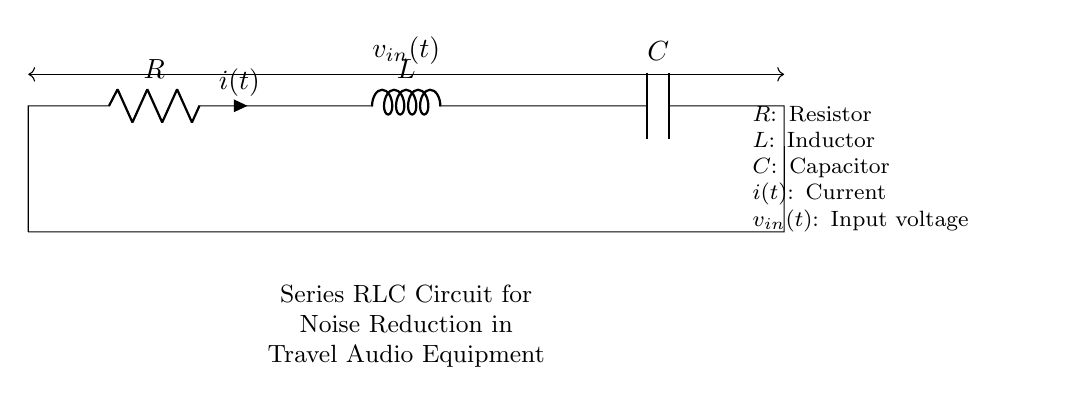What are the components of this circuit? The components listed in the circuit are Resistor, Inductor, and Capacitor, which are essential elements for filtering noise in audio equipment.
Answer: Resistor, Inductor, Capacitor What type of circuit is shown? The circuit is a Series RLC Circuit, indicated by the arrangement of the Resistor, Inductor, and Capacitor in a linear series configuration.
Answer: Series RLC Circuit What does "i(t)" represent in this circuit? "i(t)" represents the current flowing through the circuit, which varies over time as indicated by the function notation.
Answer: Current What is the function of the components in this RLC circuit? The Resistor dissipates energy as heat, the Inductor stores energy in a magnetic field, and the Capacitor stores energy in an electric field. Together they filter frequencies for noise reduction.
Answer: Noise reduction What is the input voltage symbol in this circuit? The input voltage is represented by the symbol "v_in(t)", which is the voltage applied across the entire RLC circuit.
Answer: v_in(t) What effect does increasing the Inductor's value have on the circuit? Increasing the Inductor's value will lower the resonant frequency of the circuit, making it more effective at filtering out lower frequencies, which is beneficial for noise reduction.
Answer: Lower resonant frequency What happens if we remove the Capacitor from the circuit? Removing the Capacitor would eliminate its role in filtering high-frequency noise, potentially allowing more noise from the audio signal to pass through. The circuit would then behave mainly as a resistive-inductive circuit.
Answer: Increased noise 